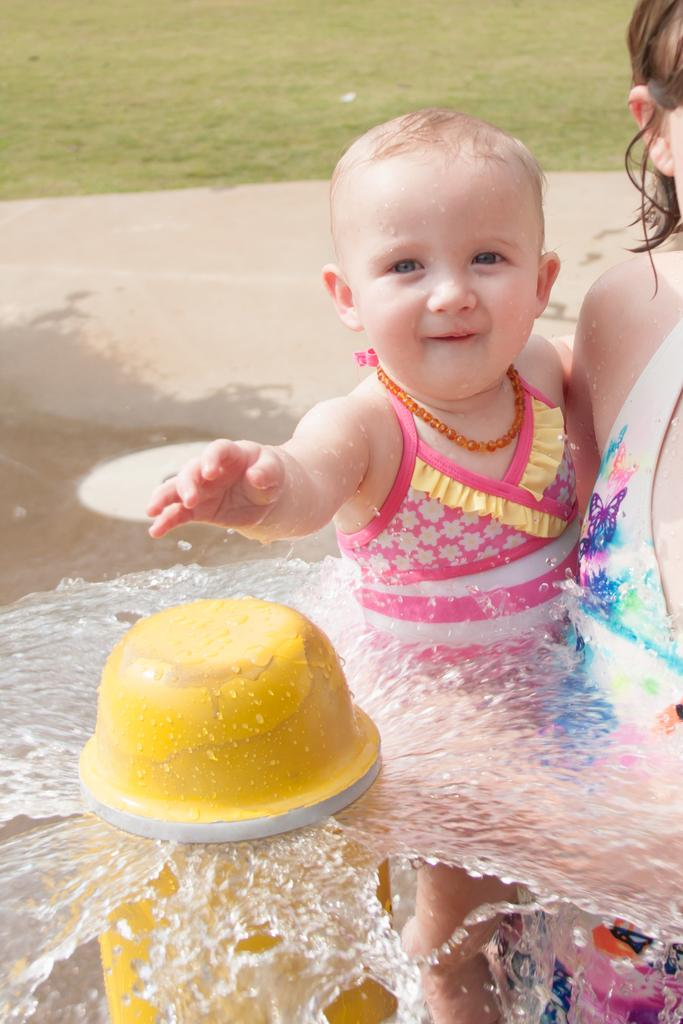Who is the main subject in the image? There is a woman in the image. What is the woman doing in the image? The woman is carrying a child. What can be seen in the background of the image? The woman and child are standing beside a water sprinkler. What type of surface is visible in the image? There is grass visible in the image. What type of beef can be seen hanging from the water sprinkler in the image? There is no beef present in the image; it features a woman carrying a child beside a water sprinkler. Can you tell me how many oceans are visible in the image? There are no oceans visible in the image; it features a woman carrying a child beside a water sprinkler on a grassy surface. 